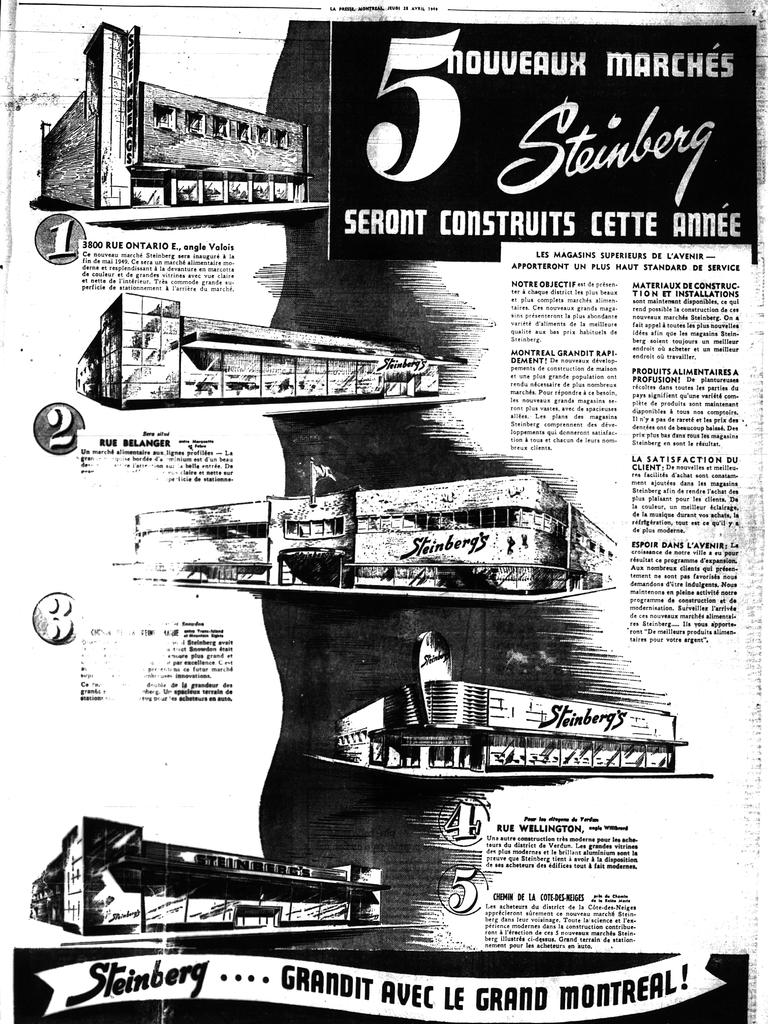<image>
Relay a brief, clear account of the picture shown. A poster in a foreign language has information about the Steinberg company. 